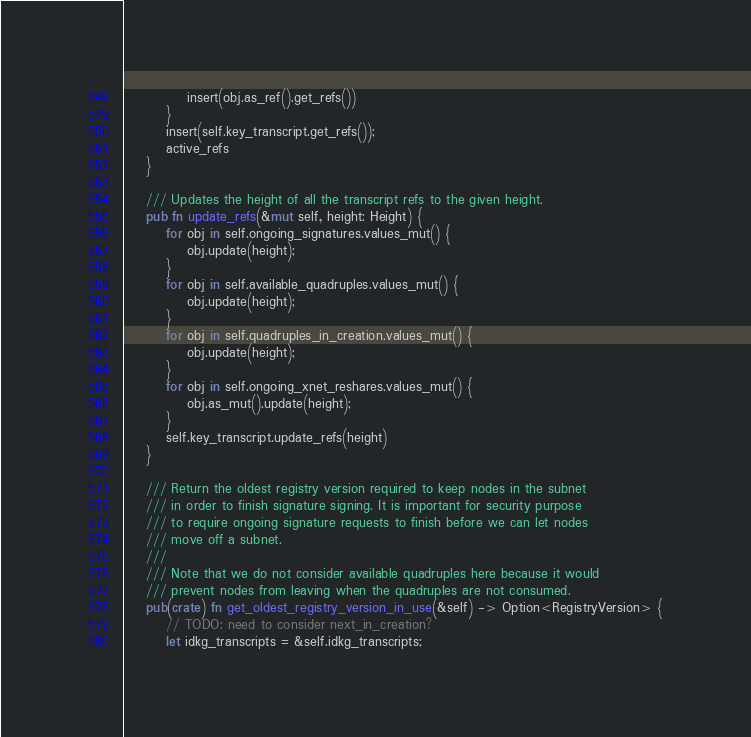<code> <loc_0><loc_0><loc_500><loc_500><_Rust_>            insert(obj.as_ref().get_refs())
        }
        insert(self.key_transcript.get_refs());
        active_refs
    }

    /// Updates the height of all the transcript refs to the given height.
    pub fn update_refs(&mut self, height: Height) {
        for obj in self.ongoing_signatures.values_mut() {
            obj.update(height);
        }
        for obj in self.available_quadruples.values_mut() {
            obj.update(height);
        }
        for obj in self.quadruples_in_creation.values_mut() {
            obj.update(height);
        }
        for obj in self.ongoing_xnet_reshares.values_mut() {
            obj.as_mut().update(height);
        }
        self.key_transcript.update_refs(height)
    }

    /// Return the oldest registry version required to keep nodes in the subnet
    /// in order to finish signature signing. It is important for security purpose
    /// to require ongoing signature requests to finish before we can let nodes
    /// move off a subnet.
    ///
    /// Note that we do not consider available quadruples here because it would
    /// prevent nodes from leaving when the quadruples are not consumed.
    pub(crate) fn get_oldest_registry_version_in_use(&self) -> Option<RegistryVersion> {
        // TODO: need to consider next_in_creation?
        let idkg_transcripts = &self.idkg_transcripts;</code> 